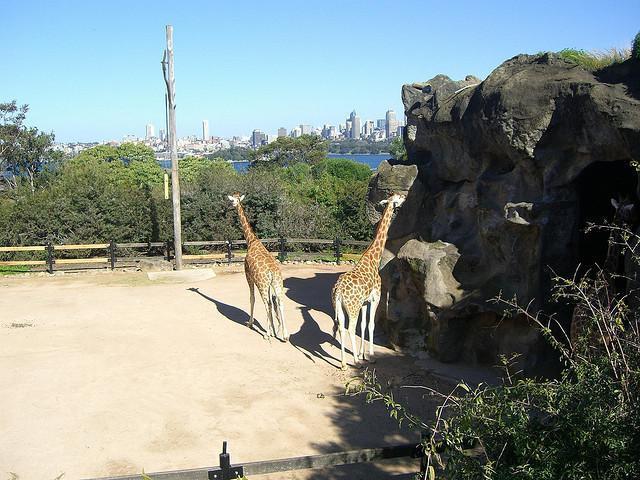How many animals are in the photo?
Give a very brief answer. 2. How many giraffes are standing?
Give a very brief answer. 2. How many giraffes are there?
Give a very brief answer. 2. 